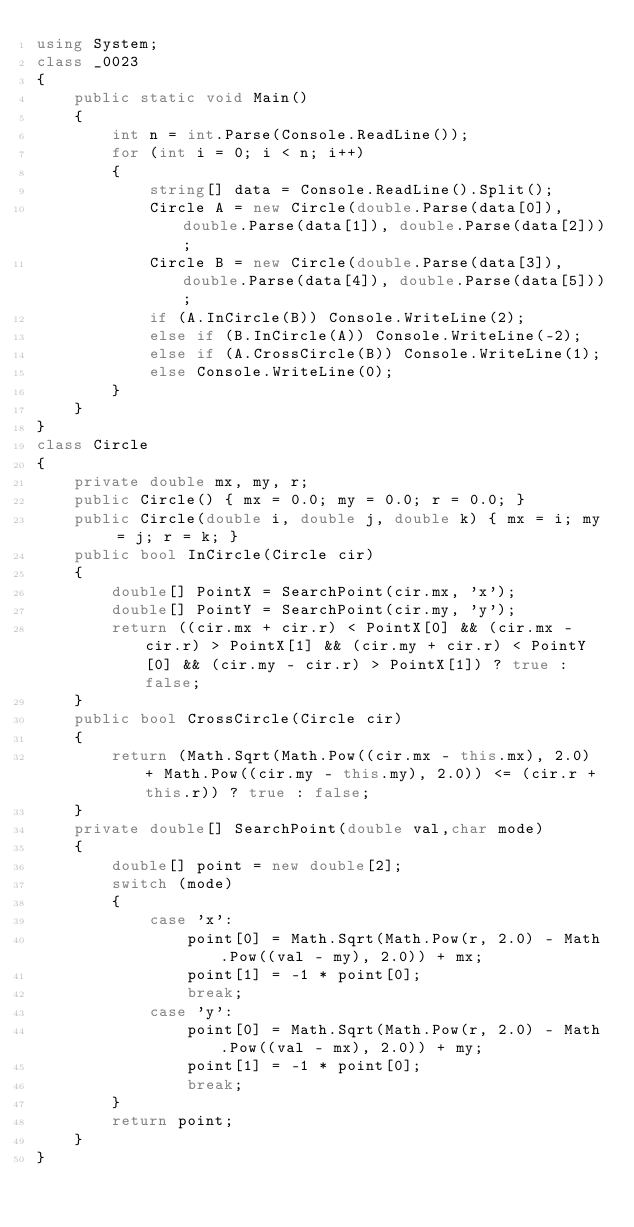<code> <loc_0><loc_0><loc_500><loc_500><_C#_>using System;
class _0023
{
    public static void Main()
    {
        int n = int.Parse(Console.ReadLine());
        for (int i = 0; i < n; i++)
        {
            string[] data = Console.ReadLine().Split();
            Circle A = new Circle(double.Parse(data[0]), double.Parse(data[1]), double.Parse(data[2]));
            Circle B = new Circle(double.Parse(data[3]), double.Parse(data[4]), double.Parse(data[5]));
            if (A.InCircle(B)) Console.WriteLine(2);
            else if (B.InCircle(A)) Console.WriteLine(-2);
            else if (A.CrossCircle(B)) Console.WriteLine(1);
            else Console.WriteLine(0);
        }
    }
}
class Circle
{
    private double mx, my, r;
    public Circle() { mx = 0.0; my = 0.0; r = 0.0; }
    public Circle(double i, double j, double k) { mx = i; my = j; r = k; }
    public bool InCircle(Circle cir)
    {
        double[] PointX = SearchPoint(cir.mx, 'x');
        double[] PointY = SearchPoint(cir.my, 'y');
        return ((cir.mx + cir.r) < PointX[0] && (cir.mx - cir.r) > PointX[1] && (cir.my + cir.r) < PointY[0] && (cir.my - cir.r) > PointX[1]) ? true : false;
    }
    public bool CrossCircle(Circle cir)
    {
        return (Math.Sqrt(Math.Pow((cir.mx - this.mx), 2.0) + Math.Pow((cir.my - this.my), 2.0)) <= (cir.r + this.r)) ? true : false;
    }
    private double[] SearchPoint(double val,char mode)
    {
        double[] point = new double[2];
        switch (mode)
        {
            case 'x':
                point[0] = Math.Sqrt(Math.Pow(r, 2.0) - Math.Pow((val - my), 2.0)) + mx;
                point[1] = -1 * point[0];
                break;
            case 'y':
                point[0] = Math.Sqrt(Math.Pow(r, 2.0) - Math.Pow((val - mx), 2.0)) + my;
                point[1] = -1 * point[0];
                break;
        }
        return point;
    }
}</code> 